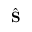<formula> <loc_0><loc_0><loc_500><loc_500>\hat { S }</formula> 